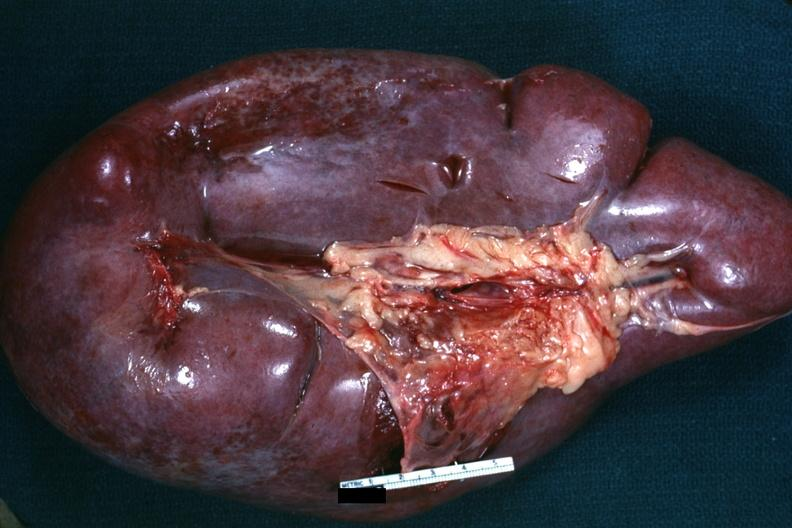s basal skull fracture present?
Answer the question using a single word or phrase. No 